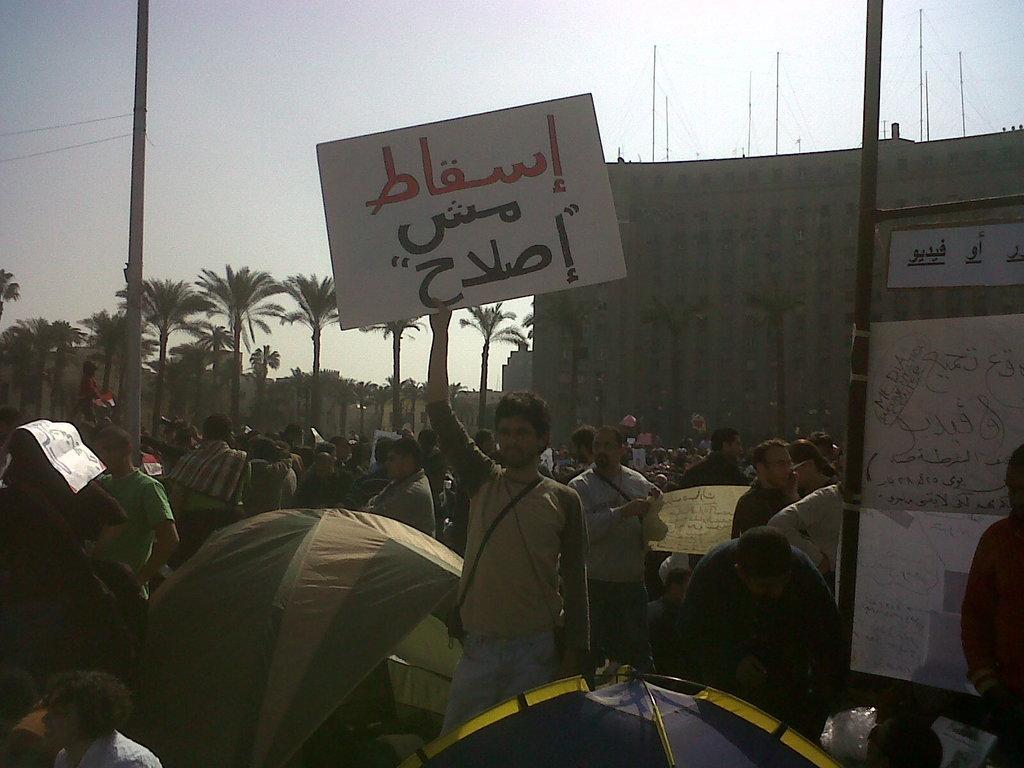Can you describe this image briefly? In this image I can see a crowd on the road, umbrellas and boards. In the background I can see a building, trees, houses, poles and the sky. This image is taken may be during a day. 